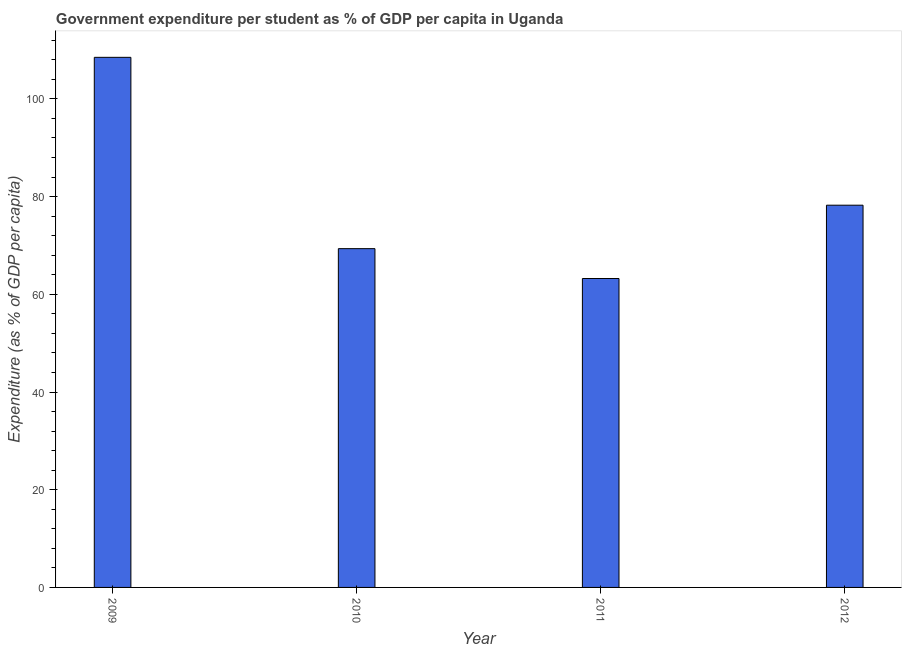Does the graph contain any zero values?
Keep it short and to the point. No. What is the title of the graph?
Your answer should be compact. Government expenditure per student as % of GDP per capita in Uganda. What is the label or title of the Y-axis?
Make the answer very short. Expenditure (as % of GDP per capita). What is the government expenditure per student in 2012?
Offer a terse response. 78.25. Across all years, what is the maximum government expenditure per student?
Offer a very short reply. 108.51. Across all years, what is the minimum government expenditure per student?
Give a very brief answer. 63.24. In which year was the government expenditure per student minimum?
Make the answer very short. 2011. What is the sum of the government expenditure per student?
Your answer should be very brief. 319.35. What is the difference between the government expenditure per student in 2010 and 2011?
Offer a very short reply. 6.11. What is the average government expenditure per student per year?
Make the answer very short. 79.84. What is the median government expenditure per student?
Your response must be concise. 73.8. What is the ratio of the government expenditure per student in 2011 to that in 2012?
Offer a terse response. 0.81. Is the government expenditure per student in 2010 less than that in 2011?
Your answer should be compact. No. What is the difference between the highest and the second highest government expenditure per student?
Offer a terse response. 30.27. Is the sum of the government expenditure per student in 2009 and 2010 greater than the maximum government expenditure per student across all years?
Offer a terse response. Yes. What is the difference between the highest and the lowest government expenditure per student?
Give a very brief answer. 45.27. In how many years, is the government expenditure per student greater than the average government expenditure per student taken over all years?
Make the answer very short. 1. How many bars are there?
Keep it short and to the point. 4. What is the difference between two consecutive major ticks on the Y-axis?
Your answer should be compact. 20. Are the values on the major ticks of Y-axis written in scientific E-notation?
Your answer should be very brief. No. What is the Expenditure (as % of GDP per capita) in 2009?
Keep it short and to the point. 108.51. What is the Expenditure (as % of GDP per capita) in 2010?
Your answer should be very brief. 69.35. What is the Expenditure (as % of GDP per capita) of 2011?
Ensure brevity in your answer.  63.24. What is the Expenditure (as % of GDP per capita) of 2012?
Ensure brevity in your answer.  78.25. What is the difference between the Expenditure (as % of GDP per capita) in 2009 and 2010?
Provide a succinct answer. 39.16. What is the difference between the Expenditure (as % of GDP per capita) in 2009 and 2011?
Your answer should be compact. 45.27. What is the difference between the Expenditure (as % of GDP per capita) in 2009 and 2012?
Keep it short and to the point. 30.27. What is the difference between the Expenditure (as % of GDP per capita) in 2010 and 2011?
Your answer should be very brief. 6.11. What is the difference between the Expenditure (as % of GDP per capita) in 2010 and 2012?
Ensure brevity in your answer.  -8.9. What is the difference between the Expenditure (as % of GDP per capita) in 2011 and 2012?
Provide a succinct answer. -15.01. What is the ratio of the Expenditure (as % of GDP per capita) in 2009 to that in 2010?
Provide a short and direct response. 1.56. What is the ratio of the Expenditure (as % of GDP per capita) in 2009 to that in 2011?
Your response must be concise. 1.72. What is the ratio of the Expenditure (as % of GDP per capita) in 2009 to that in 2012?
Ensure brevity in your answer.  1.39. What is the ratio of the Expenditure (as % of GDP per capita) in 2010 to that in 2011?
Ensure brevity in your answer.  1.1. What is the ratio of the Expenditure (as % of GDP per capita) in 2010 to that in 2012?
Give a very brief answer. 0.89. What is the ratio of the Expenditure (as % of GDP per capita) in 2011 to that in 2012?
Provide a succinct answer. 0.81. 